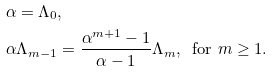<formula> <loc_0><loc_0><loc_500><loc_500>& \alpha = \Lambda _ { 0 } , \\ & \alpha \Lambda _ { m - 1 } = \frac { \alpha ^ { m + 1 } - 1 } { \alpha - 1 } \Lambda _ { m } , \, \text { for } m \geq 1 .</formula> 